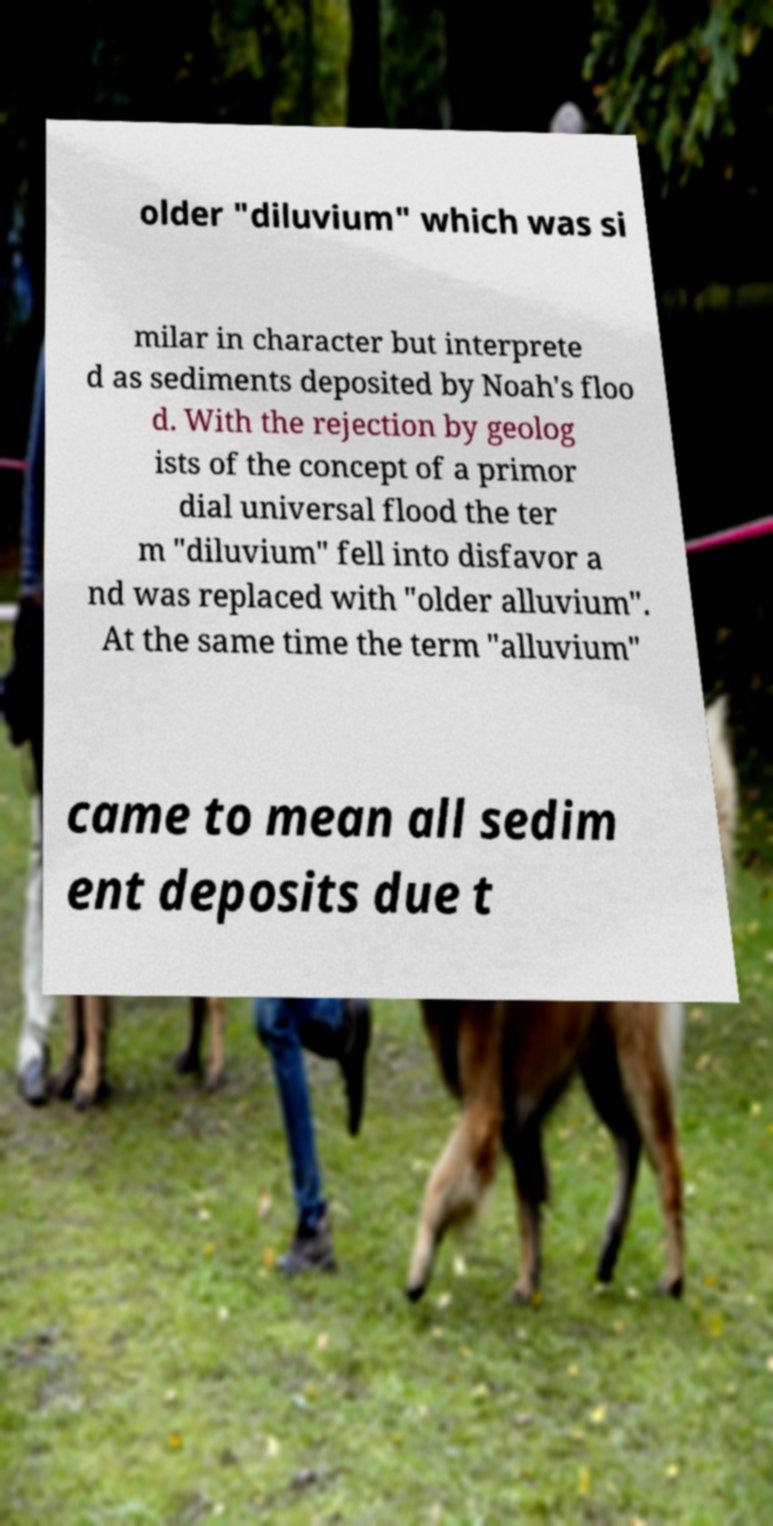Please identify and transcribe the text found in this image. older "diluvium" which was si milar in character but interprete d as sediments deposited by Noah's floo d. With the rejection by geolog ists of the concept of a primor dial universal flood the ter m "diluvium" fell into disfavor a nd was replaced with "older alluvium". At the same time the term "alluvium" came to mean all sedim ent deposits due t 